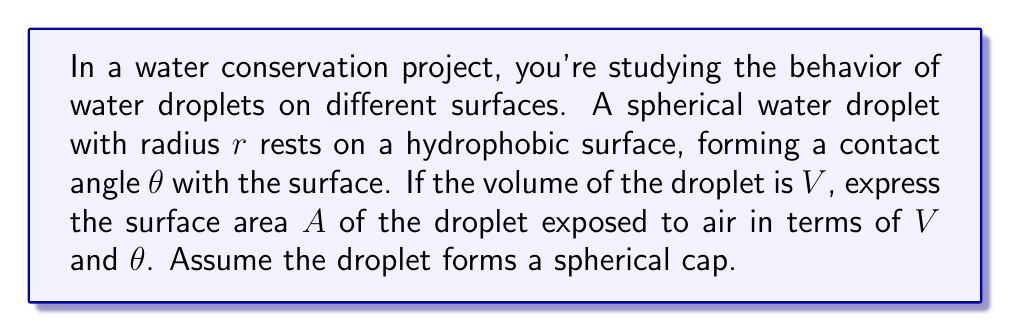Provide a solution to this math problem. Let's approach this step-by-step:

1) The volume of a spherical cap is given by:
   $$V = \frac{\pi h^2}{3}(3r - h)$$
   where $h$ is the height of the cap.

2) The radius of the base of the cap, $a$, is related to $r$ and $h$ by:
   $$a^2 = 2rh - h^2$$

3) From the contact angle $\theta$, we can deduce:
   $$\cos\theta = \frac{r-h}{r}$$
   $$h = r(1-\cos\theta)$$

4) Substituting this into the volume formula:
   $$V = \frac{\pi r^3}{3}(2-3\cos\theta+\cos^3\theta)$$

5) Solving for $r$:
   $$r = \sqrt[3]{\frac{3V}{\pi(2-3\cos\theta+\cos^3\theta)}}$$

6) The surface area of a spherical cap is given by:
   $$A = 2\pi rh = 2\pi r^2(1-\cos\theta)$$

7) Substituting the expression for $r$:
   $$A = 2\pi \left(\frac{3V}{\pi(2-3\cos\theta+\cos^3\theta)}\right)^{2/3} (1-\cos\theta)$$

8) Simplifying:
   $$A = (36\pi V^2)^{1/3} \cdot \frac{(1-\cos\theta)}{(2-3\cos\theta+\cos^3\theta)^{2/3}}$$

This expresses the surface area $A$ in terms of volume $V$ and contact angle $\theta$.
Answer: $A = (36\pi V^2)^{1/3} \cdot \frac{(1-\cos\theta)}{(2-3\cos\theta+\cos^3\theta)^{2/3}}$ 